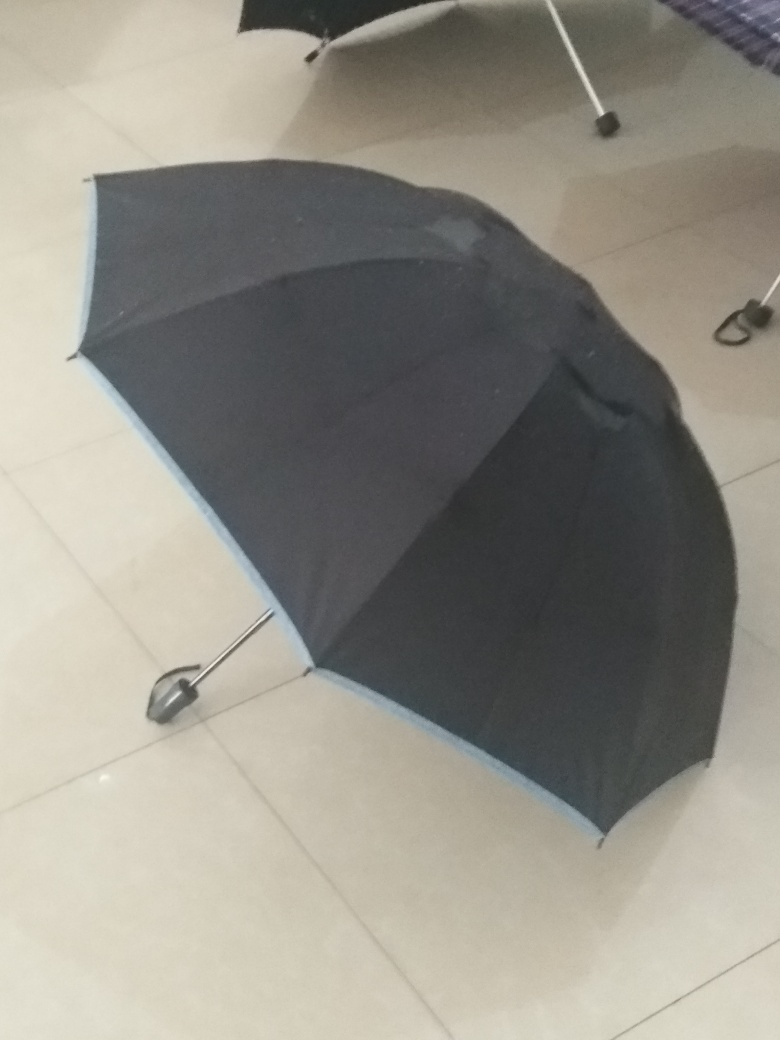Is there anything unusual about the position of the umbrella? Indeed, umbrellas are typically stored either fully closed and upright or fully open to dry. This umbrella is neither fully closed nor open, which is uncommon. It may indicate that the person using it was interrupted, or it was placed hastily. 